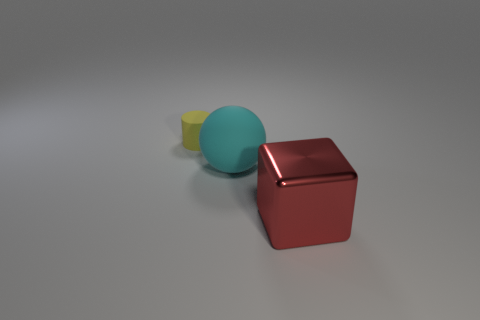Are there any cyan balls of the same size as the red shiny block?
Give a very brief answer. Yes. Do the tiny yellow thing and the big object that is behind the big red metallic object have the same shape?
Keep it short and to the point. No. There is a rubber thing that is in front of the yellow matte thing; does it have the same size as the matte thing that is behind the large cyan ball?
Your response must be concise. No. How many other things are the same shape as the big cyan matte object?
Your answer should be compact. 0. What is the material of the large thing that is in front of the rubber object that is on the right side of the cylinder?
Your answer should be compact. Metal. How many rubber things are either large balls or large things?
Offer a very short reply. 1. Is there anything else that has the same material as the yellow cylinder?
Provide a succinct answer. Yes. There is a matte thing in front of the small matte cylinder; are there any red shiny cubes that are on the left side of it?
Your answer should be very brief. No. How many objects are either rubber objects right of the tiny cylinder or matte objects that are on the left side of the big cyan sphere?
Ensure brevity in your answer.  2. Are there any other things of the same color as the big sphere?
Your answer should be compact. No. 